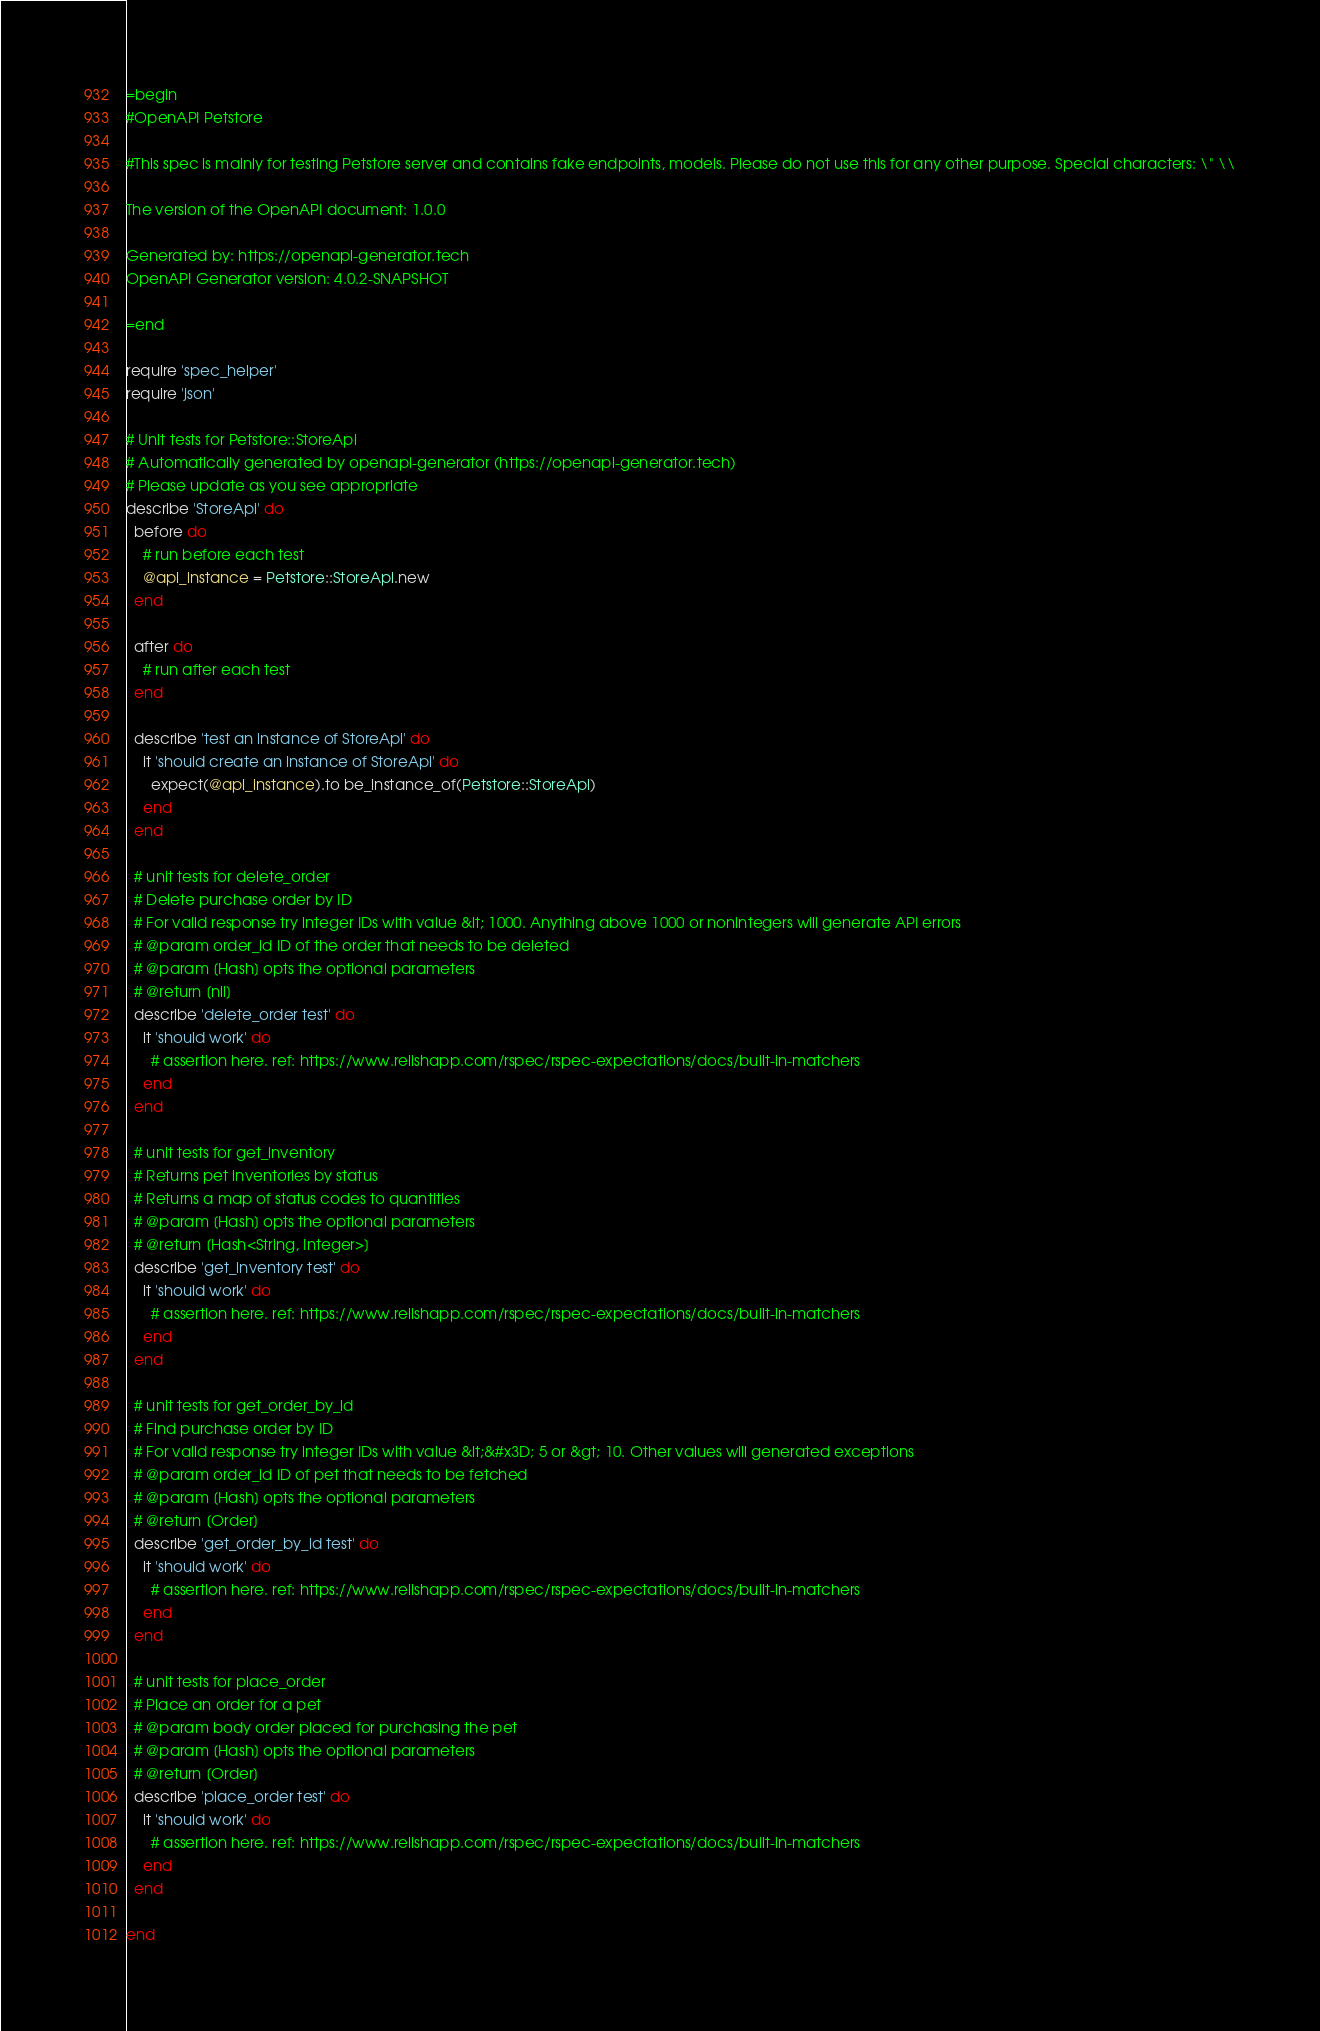Convert code to text. <code><loc_0><loc_0><loc_500><loc_500><_Ruby_>=begin
#OpenAPI Petstore

#This spec is mainly for testing Petstore server and contains fake endpoints, models. Please do not use this for any other purpose. Special characters: \" \\

The version of the OpenAPI document: 1.0.0

Generated by: https://openapi-generator.tech
OpenAPI Generator version: 4.0.2-SNAPSHOT

=end

require 'spec_helper'
require 'json'

# Unit tests for Petstore::StoreApi
# Automatically generated by openapi-generator (https://openapi-generator.tech)
# Please update as you see appropriate
describe 'StoreApi' do
  before do
    # run before each test
    @api_instance = Petstore::StoreApi.new
  end

  after do
    # run after each test
  end

  describe 'test an instance of StoreApi' do
    it 'should create an instance of StoreApi' do
      expect(@api_instance).to be_instance_of(Petstore::StoreApi)
    end
  end

  # unit tests for delete_order
  # Delete purchase order by ID
  # For valid response try integer IDs with value &lt; 1000. Anything above 1000 or nonintegers will generate API errors
  # @param order_id ID of the order that needs to be deleted
  # @param [Hash] opts the optional parameters
  # @return [nil]
  describe 'delete_order test' do
    it 'should work' do
      # assertion here. ref: https://www.relishapp.com/rspec/rspec-expectations/docs/built-in-matchers
    end
  end

  # unit tests for get_inventory
  # Returns pet inventories by status
  # Returns a map of status codes to quantities
  # @param [Hash] opts the optional parameters
  # @return [Hash<String, Integer>]
  describe 'get_inventory test' do
    it 'should work' do
      # assertion here. ref: https://www.relishapp.com/rspec/rspec-expectations/docs/built-in-matchers
    end
  end

  # unit tests for get_order_by_id
  # Find purchase order by ID
  # For valid response try integer IDs with value &lt;&#x3D; 5 or &gt; 10. Other values will generated exceptions
  # @param order_id ID of pet that needs to be fetched
  # @param [Hash] opts the optional parameters
  # @return [Order]
  describe 'get_order_by_id test' do
    it 'should work' do
      # assertion here. ref: https://www.relishapp.com/rspec/rspec-expectations/docs/built-in-matchers
    end
  end

  # unit tests for place_order
  # Place an order for a pet
  # @param body order placed for purchasing the pet
  # @param [Hash] opts the optional parameters
  # @return [Order]
  describe 'place_order test' do
    it 'should work' do
      # assertion here. ref: https://www.relishapp.com/rspec/rspec-expectations/docs/built-in-matchers
    end
  end

end
</code> 